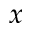Convert formula to latex. <formula><loc_0><loc_0><loc_500><loc_500>x</formula> 